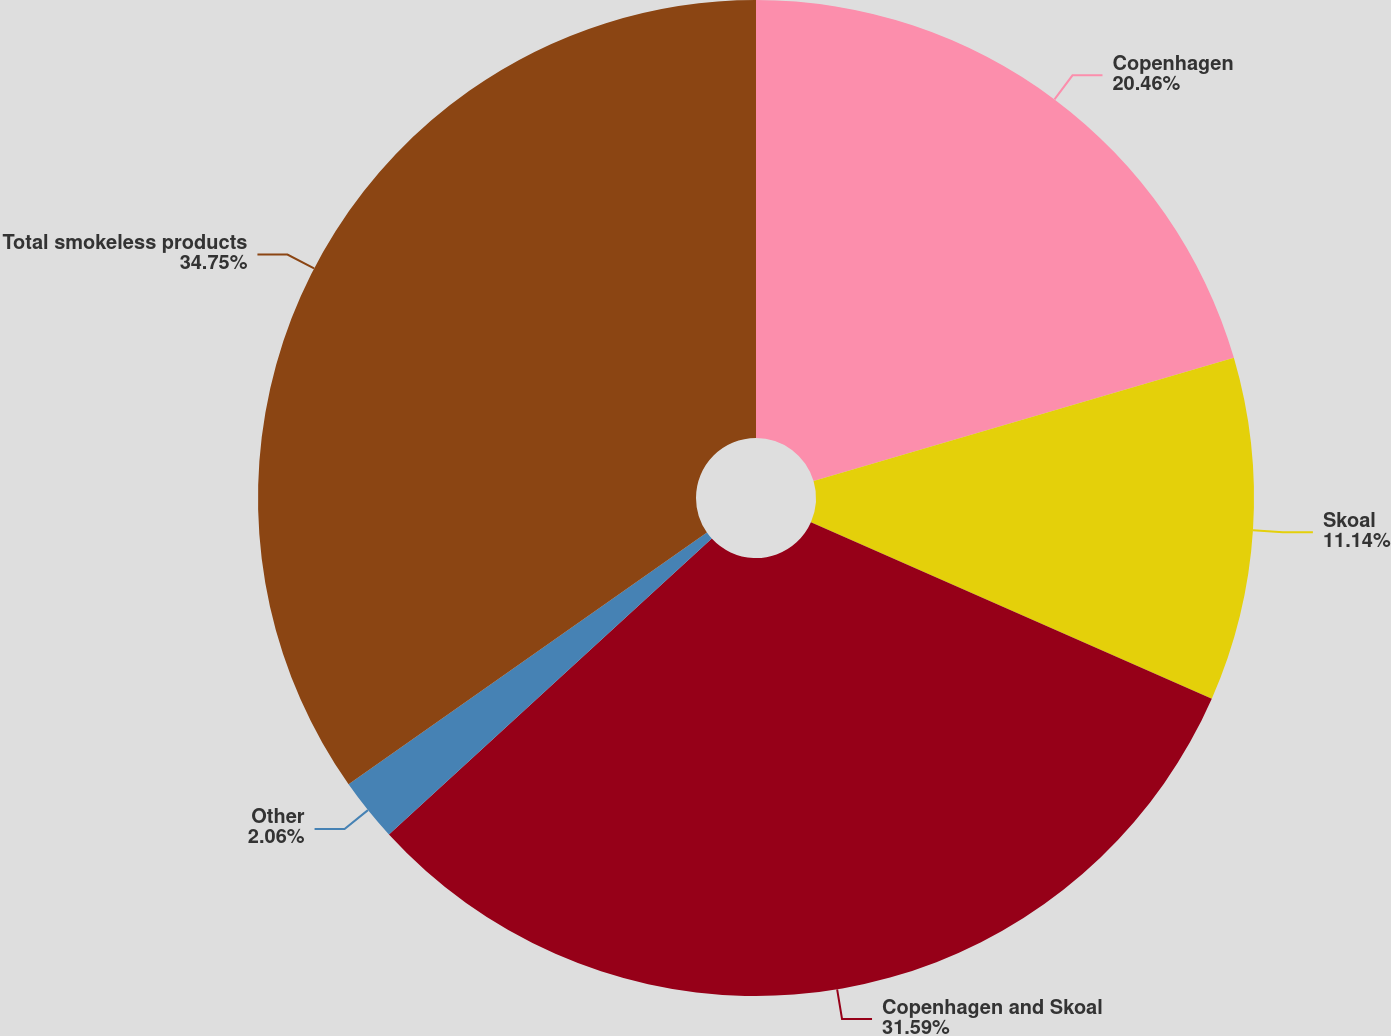<chart> <loc_0><loc_0><loc_500><loc_500><pie_chart><fcel>Copenhagen<fcel>Skoal<fcel>Copenhagen and Skoal<fcel>Other<fcel>Total smokeless products<nl><fcel>20.46%<fcel>11.14%<fcel>31.59%<fcel>2.06%<fcel>34.75%<nl></chart> 